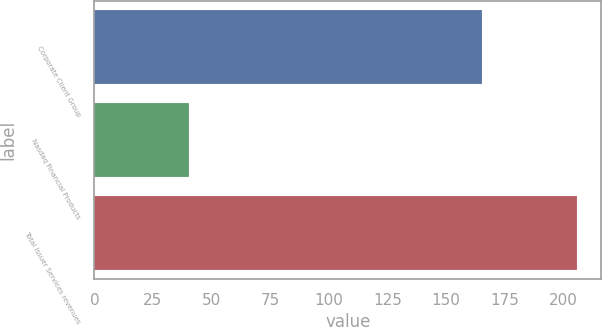Convert chart to OTSL. <chart><loc_0><loc_0><loc_500><loc_500><bar_chart><fcel>Corporate Client Group<fcel>Nasdaq Financial Products<fcel>Total Issuer Services revenues<nl><fcel>165.3<fcel>40.5<fcel>205.8<nl></chart> 